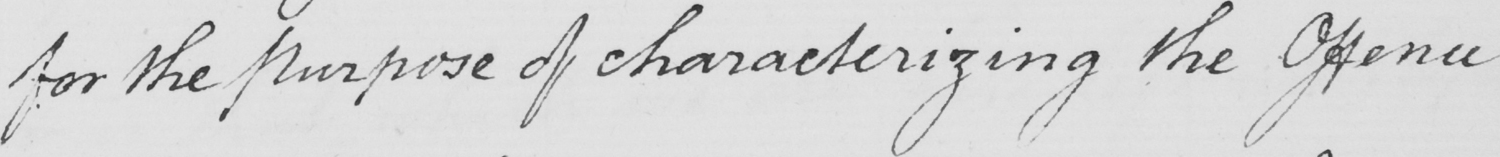Transcribe the text shown in this historical manuscript line. for the Purpose of characterizing the Offence 